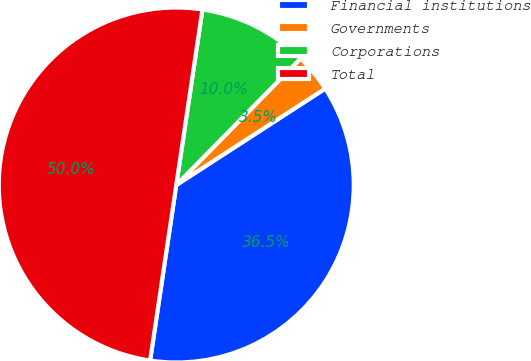<chart> <loc_0><loc_0><loc_500><loc_500><pie_chart><fcel>Financial institutions<fcel>Governments<fcel>Corporations<fcel>Total<nl><fcel>36.5%<fcel>3.5%<fcel>10.0%<fcel>50.0%<nl></chart> 